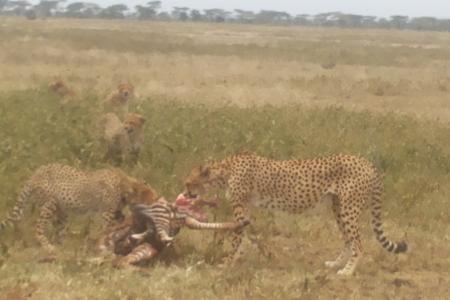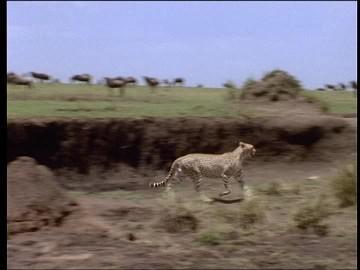The first image is the image on the left, the second image is the image on the right. For the images displayed, is the sentence "Atleast one image contains 2 cheetahs fighting another animal" factually correct? Answer yes or no. Yes. The first image is the image on the left, the second image is the image on the right. For the images displayed, is the sentence "At least one image shows only one cheetah." factually correct? Answer yes or no. Yes. 